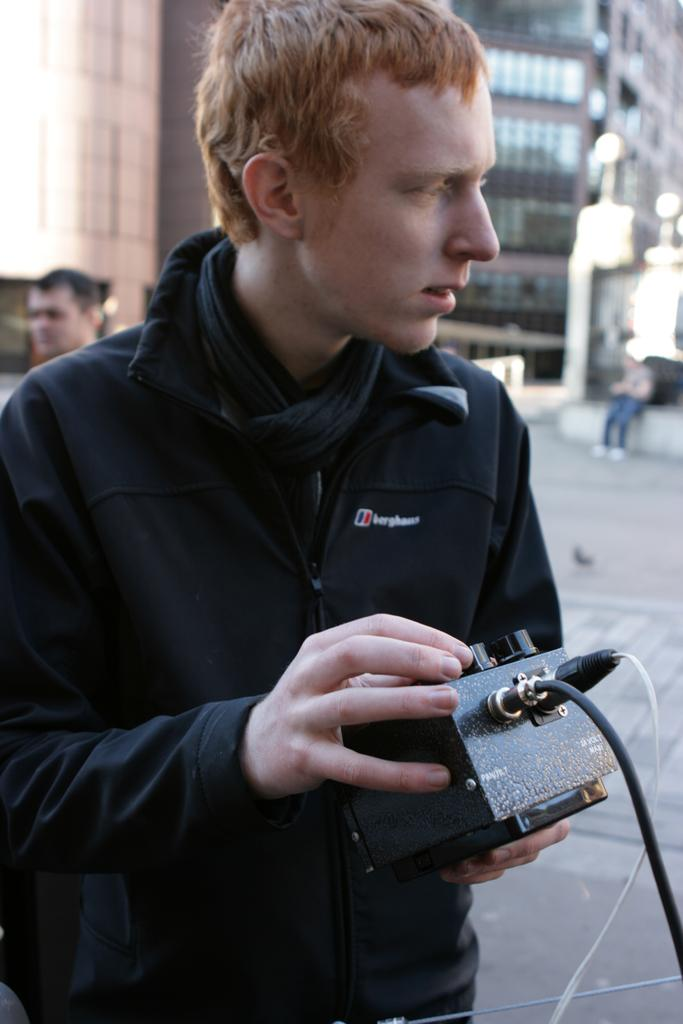What is the person holding in the image? The person is holding a metal operator in the image. What are the features of the metal operator? The metal operator contains buttons and wires. What is the position of the second person in the image? The second person is sitting on the backside the metal operator. What can be seen in the background of the image? There is a building visible in the image. What type of coach is present in the image? There is no coach present in the image. What is the wealth of the person holding the metal operator? The wealth of the person holding the metal operator cannot be determined from the image. 